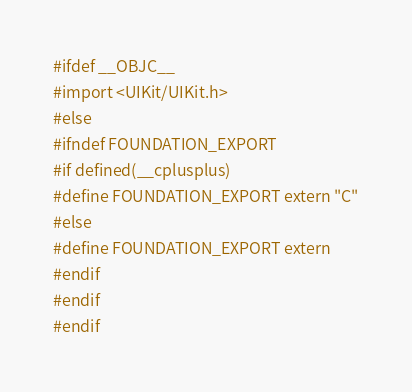<code> <loc_0><loc_0><loc_500><loc_500><_C_>#ifdef __OBJC__
#import <UIKit/UIKit.h>
#else
#ifndef FOUNDATION_EXPORT
#if defined(__cplusplus)
#define FOUNDATION_EXPORT extern "C"
#else
#define FOUNDATION_EXPORT extern
#endif
#endif
#endif

</code> 